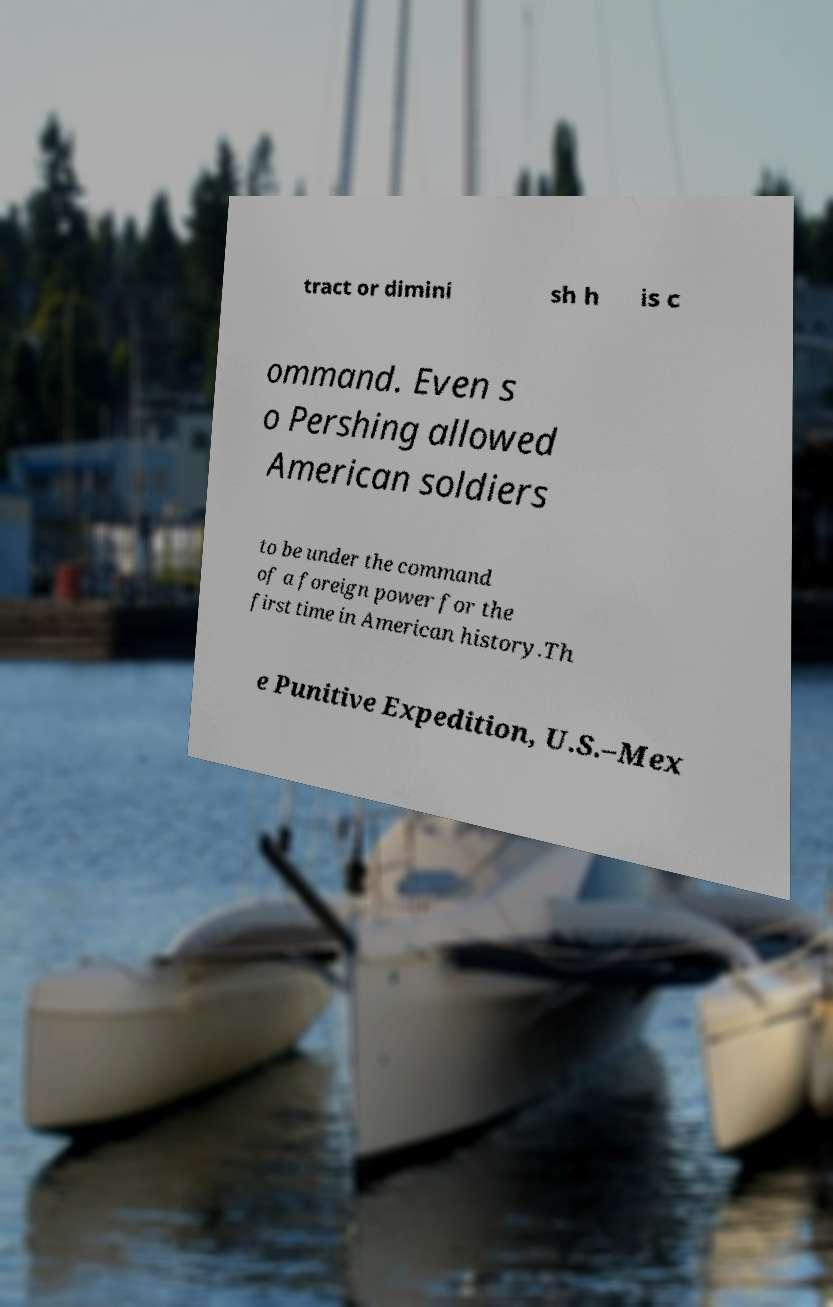For documentation purposes, I need the text within this image transcribed. Could you provide that? tract or dimini sh h is c ommand. Even s o Pershing allowed American soldiers to be under the command of a foreign power for the first time in American history.Th e Punitive Expedition, U.S.–Mex 